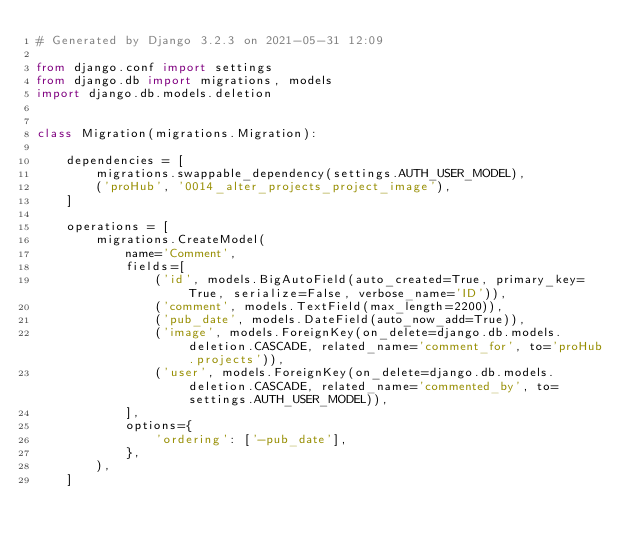<code> <loc_0><loc_0><loc_500><loc_500><_Python_># Generated by Django 3.2.3 on 2021-05-31 12:09

from django.conf import settings
from django.db import migrations, models
import django.db.models.deletion


class Migration(migrations.Migration):

    dependencies = [
        migrations.swappable_dependency(settings.AUTH_USER_MODEL),
        ('proHub', '0014_alter_projects_project_image'),
    ]

    operations = [
        migrations.CreateModel(
            name='Comment',
            fields=[
                ('id', models.BigAutoField(auto_created=True, primary_key=True, serialize=False, verbose_name='ID')),
                ('comment', models.TextField(max_length=2200)),
                ('pub_date', models.DateField(auto_now_add=True)),
                ('image', models.ForeignKey(on_delete=django.db.models.deletion.CASCADE, related_name='comment_for', to='proHub.projects')),
                ('user', models.ForeignKey(on_delete=django.db.models.deletion.CASCADE, related_name='commented_by', to=settings.AUTH_USER_MODEL)),
            ],
            options={
                'ordering': ['-pub_date'],
            },
        ),
    ]
</code> 